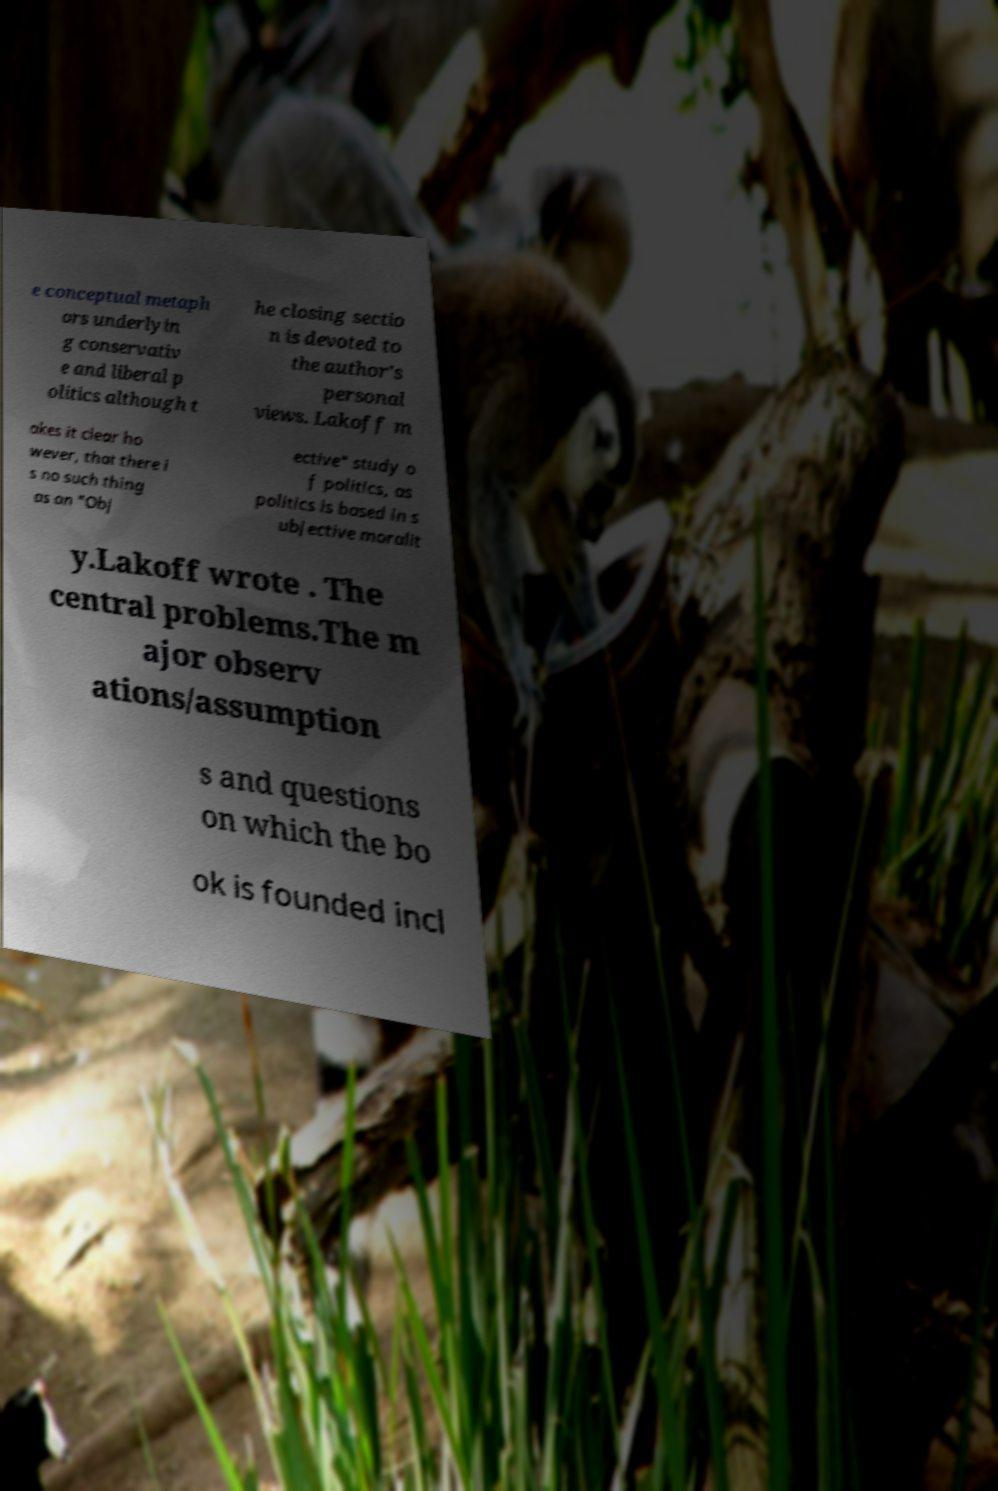Please identify and transcribe the text found in this image. e conceptual metaph ors underlyin g conservativ e and liberal p olitics although t he closing sectio n is devoted to the author's personal views. Lakoff m akes it clear ho wever, that there i s no such thing as an "Obj ective" study o f politics, as politics is based in s ubjective moralit y.Lakoff wrote . The central problems.The m ajor observ ations/assumption s and questions on which the bo ok is founded incl 